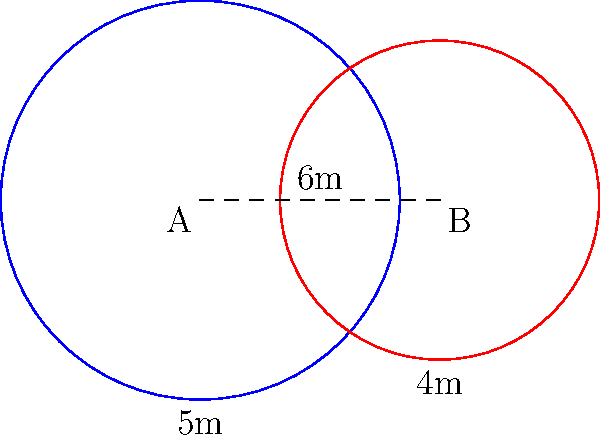During a training session, Coach Belza sets up two circular training zones on the football field. Zone A has a radius of 5 meters, and Zone B has a radius of 4 meters. The centers of these zones are 6 meters apart. Calculate the area of the overlapping region between these two zones. Round your answer to the nearest square meter. Let's approach this step-by-step:

1) First, we need to find the distance from the center of each circle to the line of intersection. Let's call this distance $x$ for circle A and $y$ for circle B.

2) We can use the Pythagorean theorem:

   $5^2 = x^2 + 3^2$ (for circle A)
   $4^2 = y^2 + 3^2$ (for circle B)

3) Solving these equations:
   $x = \sqrt{5^2 - 3^2} = 4$ meters
   $y = \sqrt{4^2 - 3^2} = \sqrt{7}$ meters

4) The area of the overlapping region is the sum of two circular segments. The area of a circular segment is given by:

   $A = r^2 \arccos(\frac{r-h}{r}) - (r-h)\sqrt{2rh-h^2}$

   where $r$ is the radius and $h$ is the height of the segment.

5) For circle A: $h_A = 5 - 4 = 1$
   For circle B: $h_B = 4 - \sqrt{7} \approx 1.3541$

6) Plugging these into the formula:

   $A_A = 5^2 \arccos(\frac{5-1}{5}) - (5-1)\sqrt{2(5)(1)-1^2} \approx 3.5973$

   $A_B = 4^2 \arccos(\frac{4-1.3541}{4}) - (4-1.3541)\sqrt{2(4)(1.3541)-1.3541^2} \approx 3.7757$

7) The total overlapping area is the sum of these segments:

   $A_{total} = A_A + A_B \approx 3.5973 + 3.7757 = 7.3730$ square meters

8) Rounding to the nearest square meter: 7 square meters.
Answer: 7 square meters 